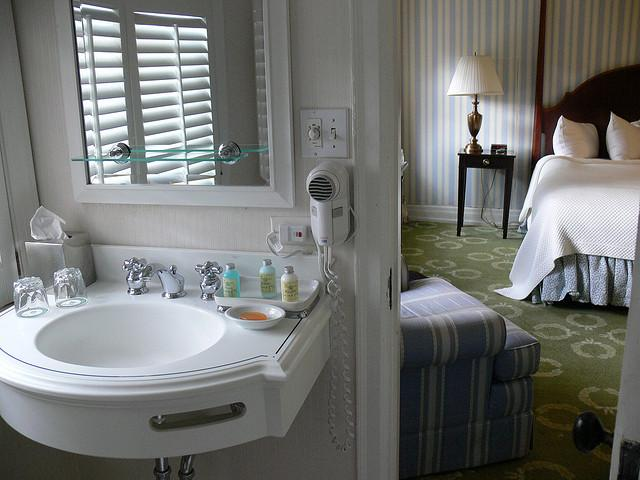What is on the bed?

Choices:
A) dogs
B) pillows
C) old man
D) cats pillows 